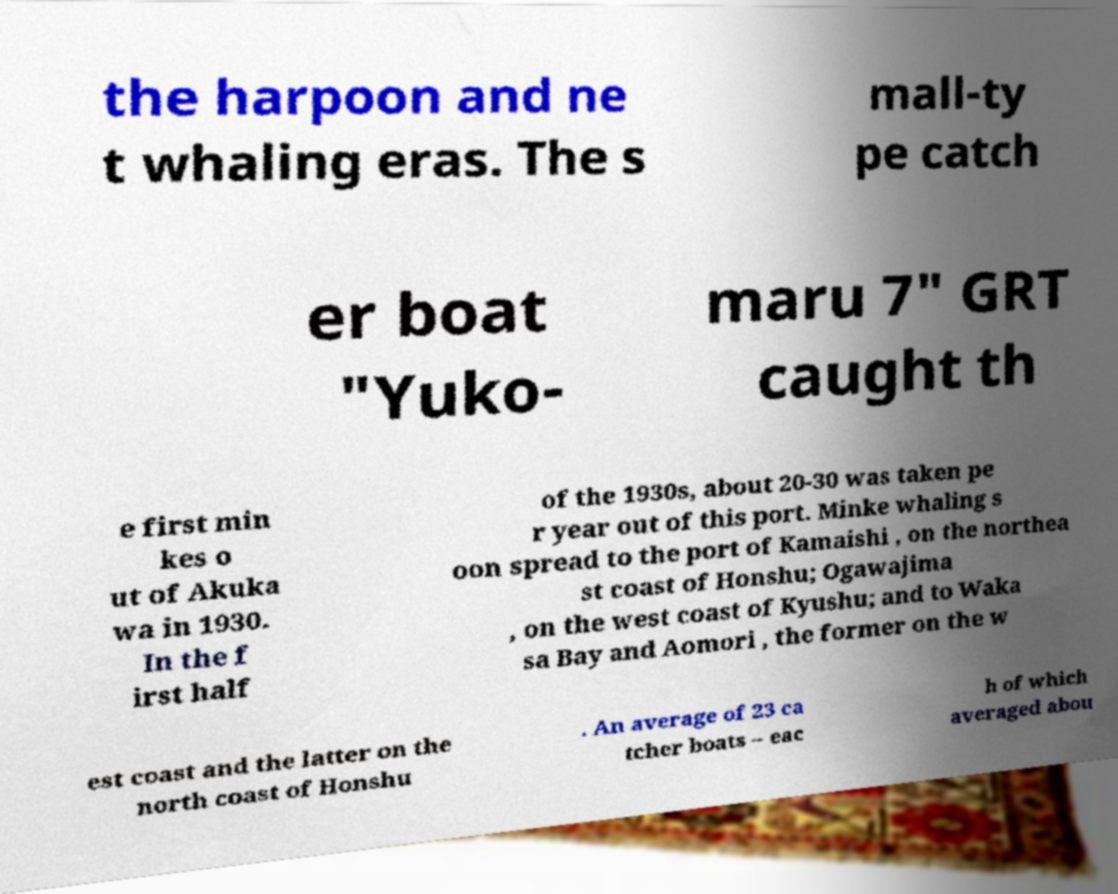Please read and relay the text visible in this image. What does it say? the harpoon and ne t whaling eras. The s mall-ty pe catch er boat "Yuko- maru 7" GRT caught th e first min kes o ut of Akuka wa in 1930. In the f irst half of the 1930s, about 20-30 was taken pe r year out of this port. Minke whaling s oon spread to the port of Kamaishi , on the northea st coast of Honshu; Ogawajima , on the west coast of Kyushu; and to Waka sa Bay and Aomori , the former on the w est coast and the latter on the north coast of Honshu . An average of 23 ca tcher boats – eac h of which averaged abou 